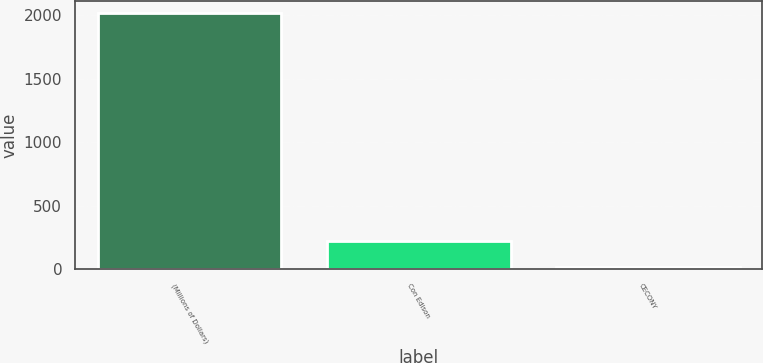<chart> <loc_0><loc_0><loc_500><loc_500><bar_chart><fcel>(Millions of Dollars)<fcel>Con Edison<fcel>CECONY<nl><fcel>2014<fcel>219.4<fcel>20<nl></chart> 